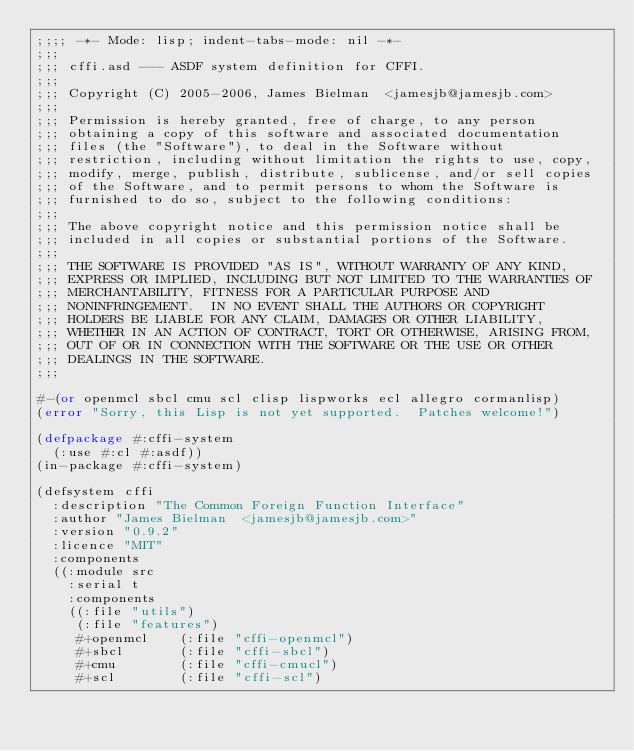Convert code to text. <code><loc_0><loc_0><loc_500><loc_500><_Lisp_>;;;; -*- Mode: lisp; indent-tabs-mode: nil -*-
;;;
;;; cffi.asd --- ASDF system definition for CFFI.
;;;
;;; Copyright (C) 2005-2006, James Bielman  <jamesjb@jamesjb.com>
;;;
;;; Permission is hereby granted, free of charge, to any person
;;; obtaining a copy of this software and associated documentation
;;; files (the "Software"), to deal in the Software without
;;; restriction, including without limitation the rights to use, copy,
;;; modify, merge, publish, distribute, sublicense, and/or sell copies
;;; of the Software, and to permit persons to whom the Software is
;;; furnished to do so, subject to the following conditions:
;;;
;;; The above copyright notice and this permission notice shall be
;;; included in all copies or substantial portions of the Software.
;;;
;;; THE SOFTWARE IS PROVIDED "AS IS", WITHOUT WARRANTY OF ANY KIND,
;;; EXPRESS OR IMPLIED, INCLUDING BUT NOT LIMITED TO THE WARRANTIES OF
;;; MERCHANTABILITY, FITNESS FOR A PARTICULAR PURPOSE AND
;;; NONINFRINGEMENT.  IN NO EVENT SHALL THE AUTHORS OR COPYRIGHT
;;; HOLDERS BE LIABLE FOR ANY CLAIM, DAMAGES OR OTHER LIABILITY,
;;; WHETHER IN AN ACTION OF CONTRACT, TORT OR OTHERWISE, ARISING FROM,
;;; OUT OF OR IN CONNECTION WITH THE SOFTWARE OR THE USE OR OTHER
;;; DEALINGS IN THE SOFTWARE.
;;;

#-(or openmcl sbcl cmu scl clisp lispworks ecl allegro cormanlisp)
(error "Sorry, this Lisp is not yet supported.  Patches welcome!")

(defpackage #:cffi-system
  (:use #:cl #:asdf))
(in-package #:cffi-system)

(defsystem cffi
  :description "The Common Foreign Function Interface"
  :author "James Bielman  <jamesjb@jamesjb.com>"
  :version "0.9.2"
  :licence "MIT"
  :components
  ((:module src
    :serial t
    :components
    ((:file "utils")
     (:file "features")
     #+openmcl    (:file "cffi-openmcl")
     #+sbcl       (:file "cffi-sbcl")
     #+cmu        (:file "cffi-cmucl")
     #+scl        (:file "cffi-scl")</code> 